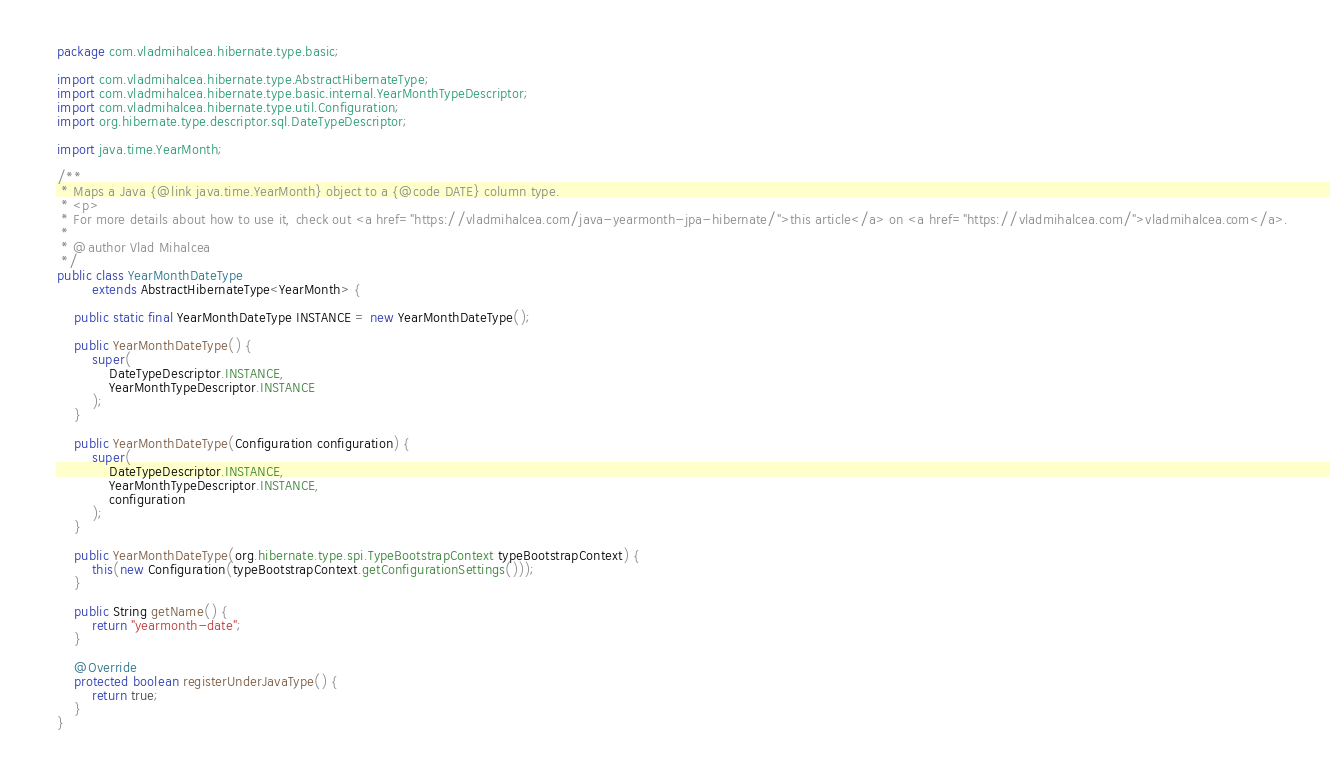<code> <loc_0><loc_0><loc_500><loc_500><_Java_>package com.vladmihalcea.hibernate.type.basic;

import com.vladmihalcea.hibernate.type.AbstractHibernateType;
import com.vladmihalcea.hibernate.type.basic.internal.YearMonthTypeDescriptor;
import com.vladmihalcea.hibernate.type.util.Configuration;
import org.hibernate.type.descriptor.sql.DateTypeDescriptor;

import java.time.YearMonth;

/**
 * Maps a Java {@link java.time.YearMonth} object to a {@code DATE} column type.
 * <p>
 * For more details about how to use it, check out <a href="https://vladmihalcea.com/java-yearmonth-jpa-hibernate/">this article</a> on <a href="https://vladmihalcea.com/">vladmihalcea.com</a>.
 *
 * @author Vlad Mihalcea
 */
public class YearMonthDateType
        extends AbstractHibernateType<YearMonth> {

    public static final YearMonthDateType INSTANCE = new YearMonthDateType();

    public YearMonthDateType() {
        super(
            DateTypeDescriptor.INSTANCE,
            YearMonthTypeDescriptor.INSTANCE
        );
    }

    public YearMonthDateType(Configuration configuration) {
        super(
            DateTypeDescriptor.INSTANCE,
            YearMonthTypeDescriptor.INSTANCE,
            configuration
        );
    }

    public YearMonthDateType(org.hibernate.type.spi.TypeBootstrapContext typeBootstrapContext) {
        this(new Configuration(typeBootstrapContext.getConfigurationSettings()));
    }

    public String getName() {
        return "yearmonth-date";
    }

    @Override
    protected boolean registerUnderJavaType() {
        return true;
    }
}</code> 